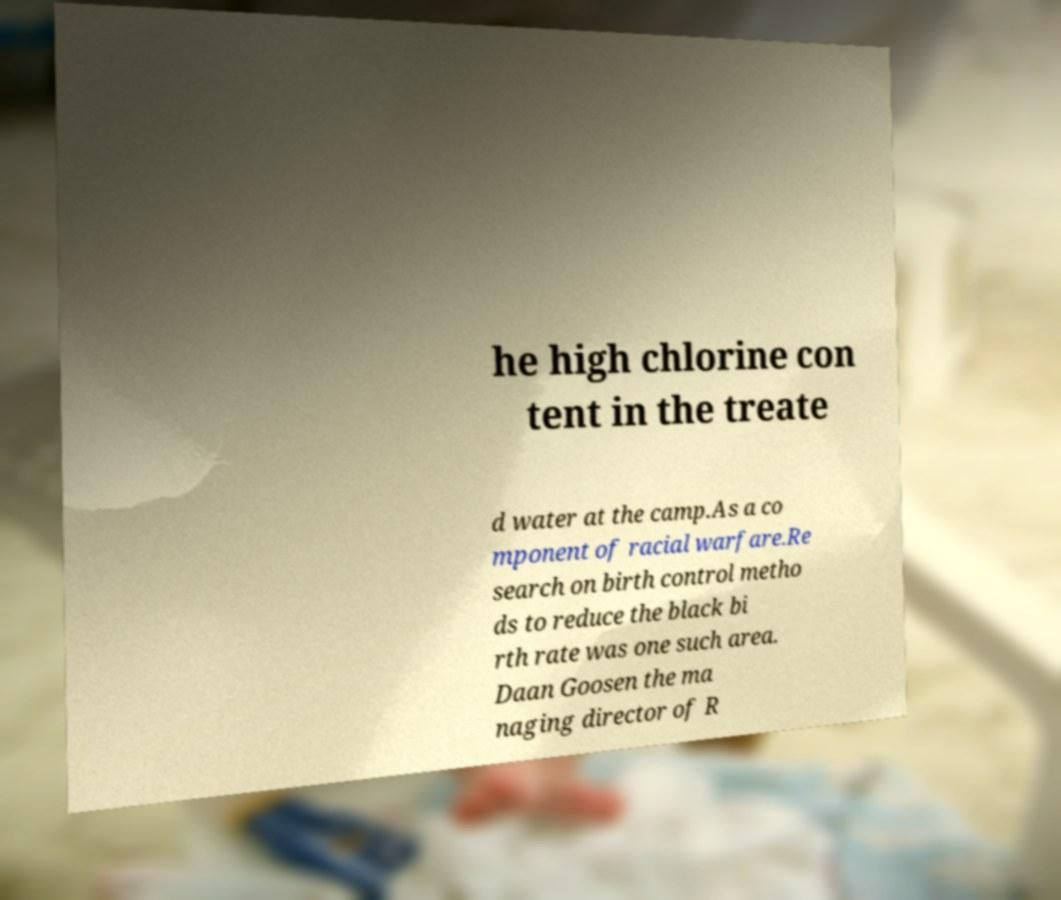Please identify and transcribe the text found in this image. he high chlorine con tent in the treate d water at the camp.As a co mponent of racial warfare.Re search on birth control metho ds to reduce the black bi rth rate was one such area. Daan Goosen the ma naging director of R 